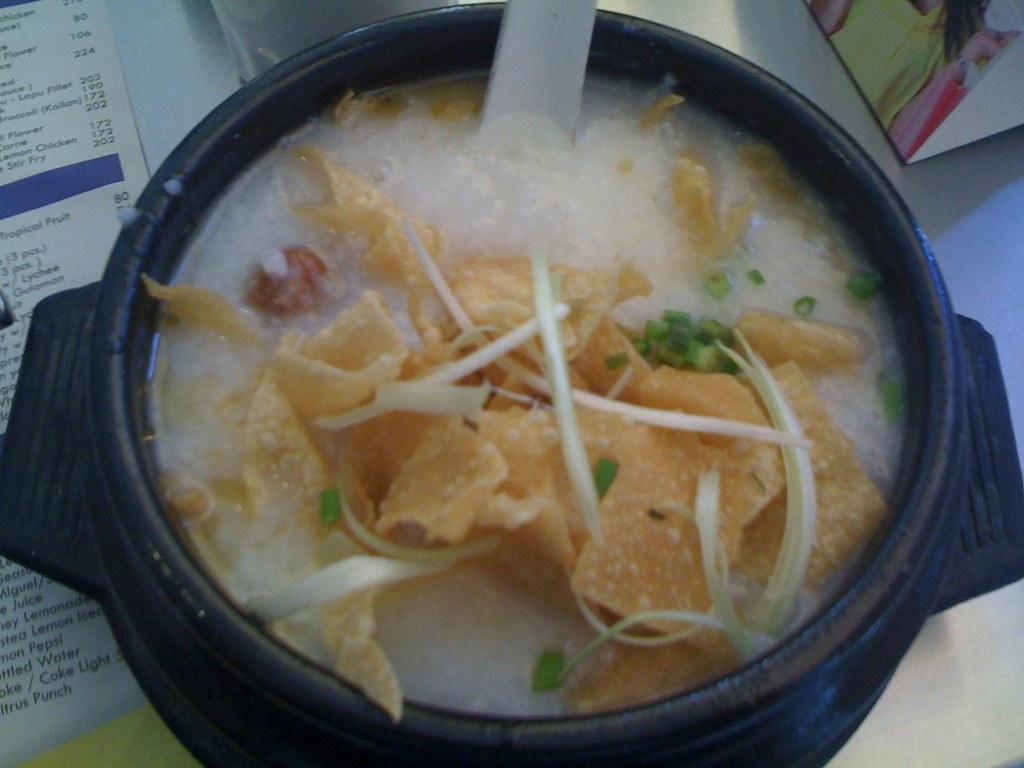What is in the bowl that is visible in the image? There is a food item in the bowl in the image. How is the food item presented in the image? The food item is on a paper. What type of surface is the bowl and food item resting on? There is a table in the image, and the bowl and food item are on it. What other objects can be seen on the table in the image? There are other objects on the table, but their specific details are not mentioned in the provided facts. Can you tell me what type of toothpaste the grandfather is using on the bridge in the image? There is no toothpaste, grandfather, or bridge present in the image. 